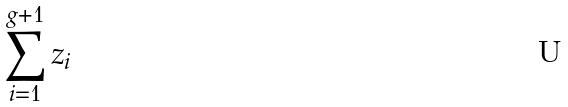<formula> <loc_0><loc_0><loc_500><loc_500>\sum _ { i = 1 } ^ { g + 1 } z _ { i }</formula> 